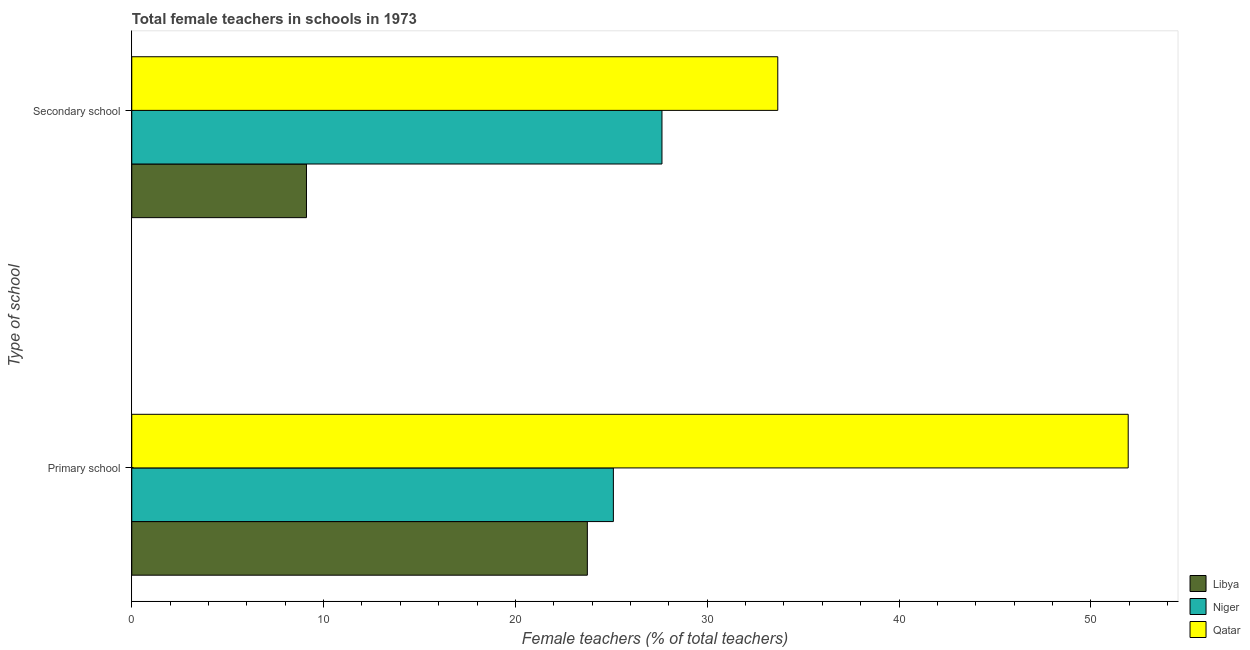Are the number of bars per tick equal to the number of legend labels?
Provide a succinct answer. Yes. Are the number of bars on each tick of the Y-axis equal?
Provide a short and direct response. Yes. How many bars are there on the 2nd tick from the top?
Offer a terse response. 3. How many bars are there on the 1st tick from the bottom?
Ensure brevity in your answer.  3. What is the label of the 2nd group of bars from the top?
Your answer should be compact. Primary school. What is the percentage of female teachers in secondary schools in Libya?
Keep it short and to the point. 9.11. Across all countries, what is the maximum percentage of female teachers in secondary schools?
Ensure brevity in your answer.  33.68. Across all countries, what is the minimum percentage of female teachers in secondary schools?
Keep it short and to the point. 9.11. In which country was the percentage of female teachers in secondary schools maximum?
Your response must be concise. Qatar. In which country was the percentage of female teachers in primary schools minimum?
Make the answer very short. Libya. What is the total percentage of female teachers in secondary schools in the graph?
Your answer should be compact. 70.43. What is the difference between the percentage of female teachers in primary schools in Qatar and that in Libya?
Offer a very short reply. 28.2. What is the difference between the percentage of female teachers in primary schools in Niger and the percentage of female teachers in secondary schools in Qatar?
Make the answer very short. -8.57. What is the average percentage of female teachers in primary schools per country?
Your answer should be compact. 33.6. What is the difference between the percentage of female teachers in secondary schools and percentage of female teachers in primary schools in Qatar?
Give a very brief answer. -18.27. In how many countries, is the percentage of female teachers in primary schools greater than 46 %?
Your response must be concise. 1. What is the ratio of the percentage of female teachers in secondary schools in Niger to that in Qatar?
Provide a succinct answer. 0.82. Is the percentage of female teachers in secondary schools in Qatar less than that in Libya?
Your answer should be compact. No. In how many countries, is the percentage of female teachers in secondary schools greater than the average percentage of female teachers in secondary schools taken over all countries?
Your answer should be compact. 2. What does the 1st bar from the top in Secondary school represents?
Ensure brevity in your answer.  Qatar. What does the 2nd bar from the bottom in Primary school represents?
Your response must be concise. Niger. How many bars are there?
Ensure brevity in your answer.  6. Are all the bars in the graph horizontal?
Make the answer very short. Yes. How many countries are there in the graph?
Give a very brief answer. 3. Are the values on the major ticks of X-axis written in scientific E-notation?
Provide a short and direct response. No. Does the graph contain any zero values?
Your answer should be very brief. No. Does the graph contain grids?
Provide a short and direct response. No. Where does the legend appear in the graph?
Ensure brevity in your answer.  Bottom right. How many legend labels are there?
Offer a terse response. 3. How are the legend labels stacked?
Ensure brevity in your answer.  Vertical. What is the title of the graph?
Give a very brief answer. Total female teachers in schools in 1973. Does "Australia" appear as one of the legend labels in the graph?
Make the answer very short. No. What is the label or title of the X-axis?
Provide a succinct answer. Female teachers (% of total teachers). What is the label or title of the Y-axis?
Give a very brief answer. Type of school. What is the Female teachers (% of total teachers) in Libya in Primary school?
Ensure brevity in your answer.  23.75. What is the Female teachers (% of total teachers) of Niger in Primary school?
Your answer should be very brief. 25.11. What is the Female teachers (% of total teachers) in Qatar in Primary school?
Make the answer very short. 51.95. What is the Female teachers (% of total teachers) of Libya in Secondary school?
Provide a succinct answer. 9.11. What is the Female teachers (% of total teachers) in Niger in Secondary school?
Give a very brief answer. 27.64. What is the Female teachers (% of total teachers) of Qatar in Secondary school?
Your answer should be very brief. 33.68. Across all Type of school, what is the maximum Female teachers (% of total teachers) of Libya?
Keep it short and to the point. 23.75. Across all Type of school, what is the maximum Female teachers (% of total teachers) of Niger?
Make the answer very short. 27.64. Across all Type of school, what is the maximum Female teachers (% of total teachers) in Qatar?
Offer a terse response. 51.95. Across all Type of school, what is the minimum Female teachers (% of total teachers) of Libya?
Offer a very short reply. 9.11. Across all Type of school, what is the minimum Female teachers (% of total teachers) of Niger?
Keep it short and to the point. 25.11. Across all Type of school, what is the minimum Female teachers (% of total teachers) of Qatar?
Your answer should be very brief. 33.68. What is the total Female teachers (% of total teachers) of Libya in the graph?
Provide a succinct answer. 32.86. What is the total Female teachers (% of total teachers) of Niger in the graph?
Provide a short and direct response. 52.75. What is the total Female teachers (% of total teachers) of Qatar in the graph?
Provide a succinct answer. 85.63. What is the difference between the Female teachers (% of total teachers) of Libya in Primary school and that in Secondary school?
Offer a very short reply. 14.64. What is the difference between the Female teachers (% of total teachers) of Niger in Primary school and that in Secondary school?
Give a very brief answer. -2.53. What is the difference between the Female teachers (% of total teachers) of Qatar in Primary school and that in Secondary school?
Your response must be concise. 18.27. What is the difference between the Female teachers (% of total teachers) in Libya in Primary school and the Female teachers (% of total teachers) in Niger in Secondary school?
Provide a succinct answer. -3.89. What is the difference between the Female teachers (% of total teachers) of Libya in Primary school and the Female teachers (% of total teachers) of Qatar in Secondary school?
Your answer should be compact. -9.93. What is the difference between the Female teachers (% of total teachers) of Niger in Primary school and the Female teachers (% of total teachers) of Qatar in Secondary school?
Provide a succinct answer. -8.57. What is the average Female teachers (% of total teachers) of Libya per Type of school?
Your answer should be very brief. 16.43. What is the average Female teachers (% of total teachers) of Niger per Type of school?
Your response must be concise. 26.38. What is the average Female teachers (% of total teachers) of Qatar per Type of school?
Keep it short and to the point. 42.81. What is the difference between the Female teachers (% of total teachers) in Libya and Female teachers (% of total teachers) in Niger in Primary school?
Provide a short and direct response. -1.36. What is the difference between the Female teachers (% of total teachers) in Libya and Female teachers (% of total teachers) in Qatar in Primary school?
Offer a terse response. -28.2. What is the difference between the Female teachers (% of total teachers) in Niger and Female teachers (% of total teachers) in Qatar in Primary school?
Your answer should be compact. -26.84. What is the difference between the Female teachers (% of total teachers) of Libya and Female teachers (% of total teachers) of Niger in Secondary school?
Your response must be concise. -18.53. What is the difference between the Female teachers (% of total teachers) in Libya and Female teachers (% of total teachers) in Qatar in Secondary school?
Your answer should be compact. -24.57. What is the difference between the Female teachers (% of total teachers) of Niger and Female teachers (% of total teachers) of Qatar in Secondary school?
Provide a succinct answer. -6.04. What is the ratio of the Female teachers (% of total teachers) of Libya in Primary school to that in Secondary school?
Offer a very short reply. 2.61. What is the ratio of the Female teachers (% of total teachers) of Niger in Primary school to that in Secondary school?
Your answer should be very brief. 0.91. What is the ratio of the Female teachers (% of total teachers) of Qatar in Primary school to that in Secondary school?
Your response must be concise. 1.54. What is the difference between the highest and the second highest Female teachers (% of total teachers) in Libya?
Make the answer very short. 14.64. What is the difference between the highest and the second highest Female teachers (% of total teachers) in Niger?
Ensure brevity in your answer.  2.53. What is the difference between the highest and the second highest Female teachers (% of total teachers) of Qatar?
Make the answer very short. 18.27. What is the difference between the highest and the lowest Female teachers (% of total teachers) in Libya?
Ensure brevity in your answer.  14.64. What is the difference between the highest and the lowest Female teachers (% of total teachers) of Niger?
Make the answer very short. 2.53. What is the difference between the highest and the lowest Female teachers (% of total teachers) of Qatar?
Offer a very short reply. 18.27. 